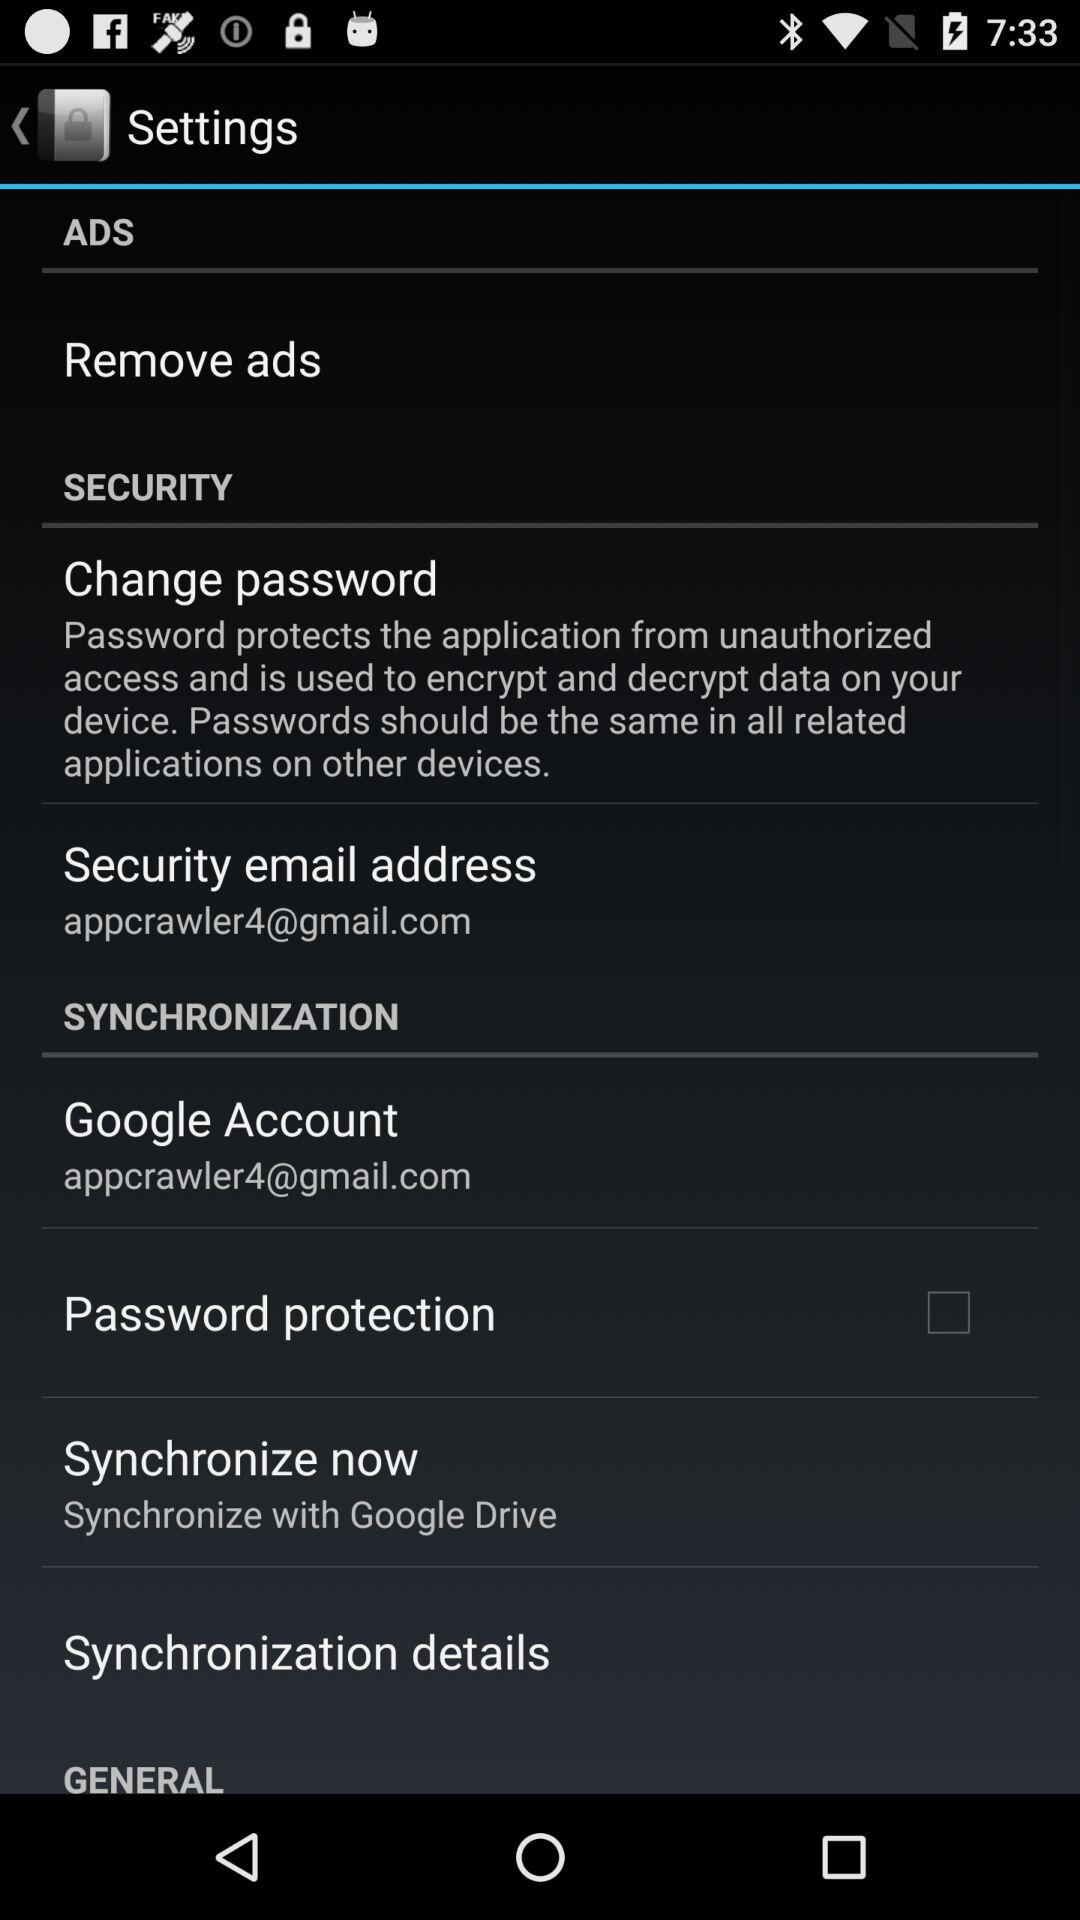What is the email address of "Google Account"? The email address is appcrawler4@gmail.com. 